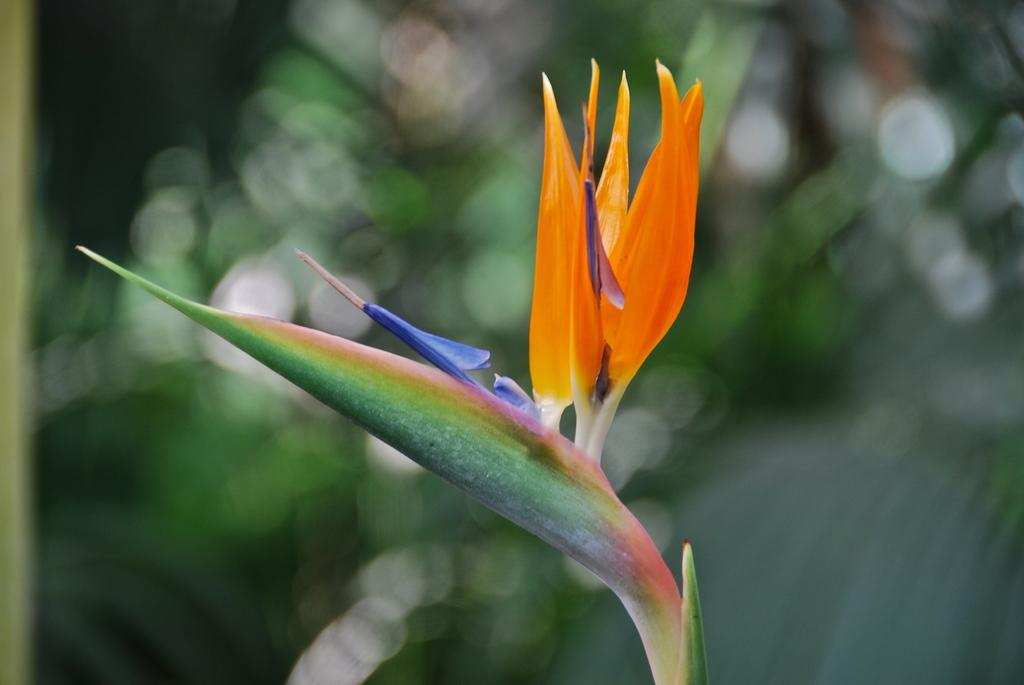What is located in the foreground area of the image? There is a plant in the foreground area of the image. How many passengers are visible in the image? There are no passengers present in the image, as it features a plant in the foreground area. What type of clothing are the women wearing in the image? There are no women present in the image, as it features a plant in the foreground area. 